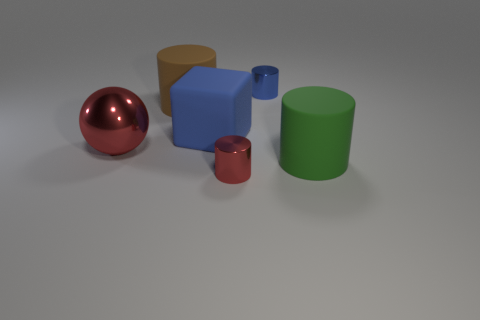Are there any blue matte cubes behind the big blue block?
Offer a very short reply. No. There is a small metal cylinder behind the small red metallic cylinder; are there any large matte cylinders that are to the right of it?
Offer a terse response. Yes. Are there an equal number of small red things that are behind the tiny blue cylinder and rubber cylinders in front of the small red object?
Provide a short and direct response. Yes. The other big cylinder that is the same material as the green cylinder is what color?
Your answer should be very brief. Brown. Are there any blue blocks made of the same material as the brown cylinder?
Your response must be concise. Yes. How many objects are green objects or red metallic objects?
Provide a short and direct response. 3. Is the blue block made of the same material as the red object to the left of the brown cylinder?
Provide a short and direct response. No. There is a rubber cylinder that is behind the big red metallic sphere; what size is it?
Your response must be concise. Large. Are there fewer red spheres than rubber objects?
Your answer should be very brief. Yes. Are there any cylinders of the same color as the ball?
Your answer should be very brief. Yes. 